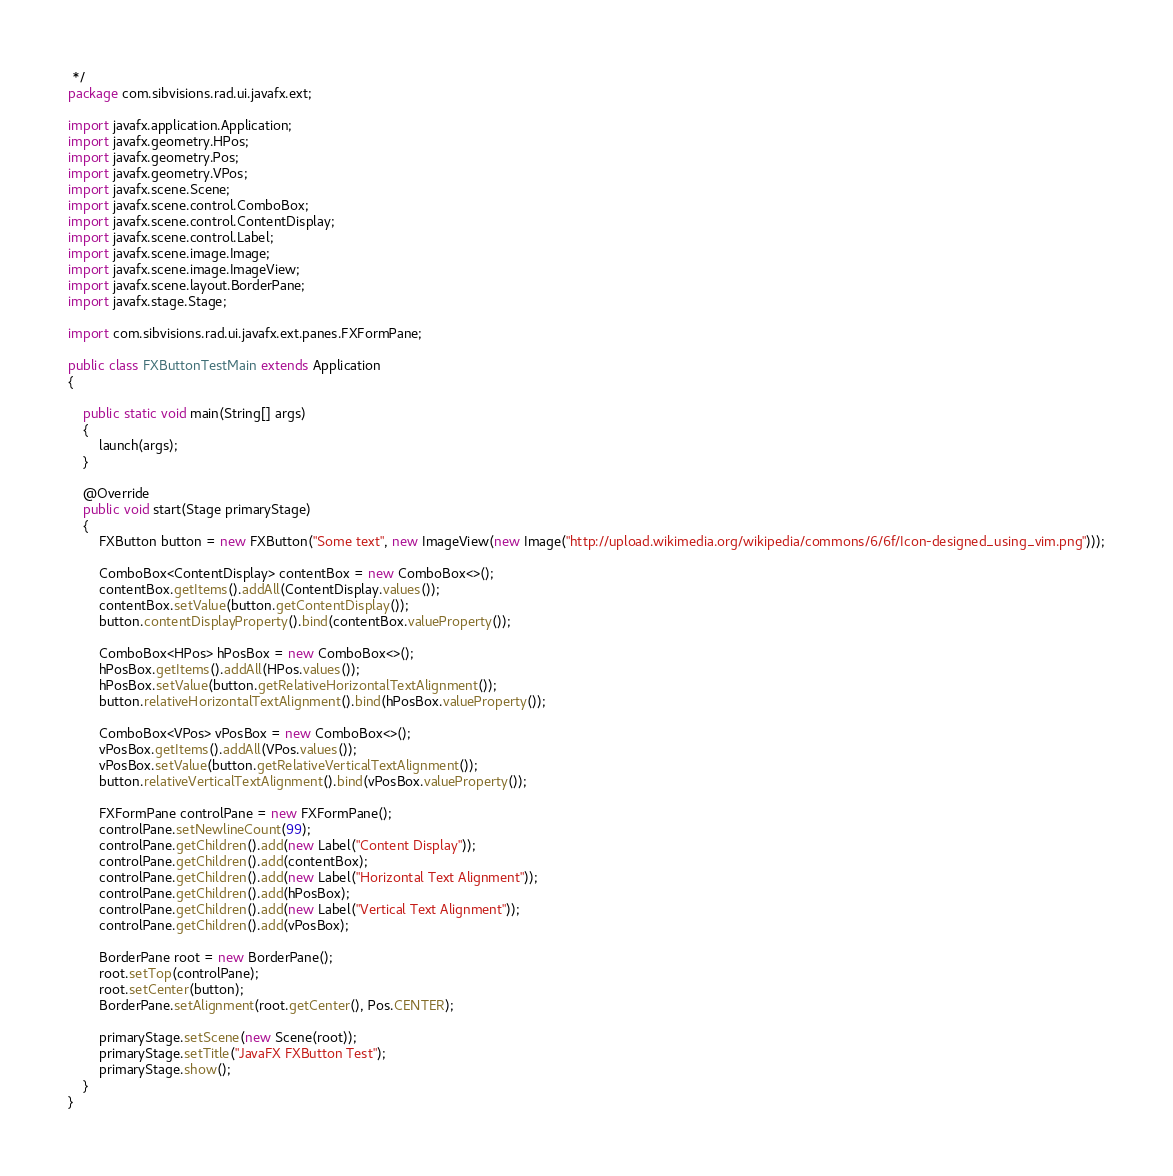<code> <loc_0><loc_0><loc_500><loc_500><_Java_> */
package com.sibvisions.rad.ui.javafx.ext;

import javafx.application.Application;
import javafx.geometry.HPos;
import javafx.geometry.Pos;
import javafx.geometry.VPos;
import javafx.scene.Scene;
import javafx.scene.control.ComboBox;
import javafx.scene.control.ContentDisplay;
import javafx.scene.control.Label;
import javafx.scene.image.Image;
import javafx.scene.image.ImageView;
import javafx.scene.layout.BorderPane;
import javafx.stage.Stage;

import com.sibvisions.rad.ui.javafx.ext.panes.FXFormPane;

public class FXButtonTestMain extends Application
{
	
	public static void main(String[] args)
	{
		launch(args);
	}
	
	@Override
	public void start(Stage primaryStage)
	{
		FXButton button = new FXButton("Some text", new ImageView(new Image("http://upload.wikimedia.org/wikipedia/commons/6/6f/Icon-designed_using_vim.png")));
		
		ComboBox<ContentDisplay> contentBox = new ComboBox<>();
		contentBox.getItems().addAll(ContentDisplay.values());
		contentBox.setValue(button.getContentDisplay());
		button.contentDisplayProperty().bind(contentBox.valueProperty());
		
		ComboBox<HPos> hPosBox = new ComboBox<>();
		hPosBox.getItems().addAll(HPos.values());
		hPosBox.setValue(button.getRelativeHorizontalTextAlignment());
		button.relativeHorizontalTextAlignment().bind(hPosBox.valueProperty());
		
		ComboBox<VPos> vPosBox = new ComboBox<>();
		vPosBox.getItems().addAll(VPos.values());
		vPosBox.setValue(button.getRelativeVerticalTextAlignment());
		button.relativeVerticalTextAlignment().bind(vPosBox.valueProperty());
		
		FXFormPane controlPane = new FXFormPane();
		controlPane.setNewlineCount(99);
		controlPane.getChildren().add(new Label("Content Display"));
		controlPane.getChildren().add(contentBox);
		controlPane.getChildren().add(new Label("Horizontal Text Alignment"));
		controlPane.getChildren().add(hPosBox);
		controlPane.getChildren().add(new Label("Vertical Text Alignment"));
		controlPane.getChildren().add(vPosBox);
		
		BorderPane root = new BorderPane();
		root.setTop(controlPane);
		root.setCenter(button);
		BorderPane.setAlignment(root.getCenter(), Pos.CENTER);
		
		primaryStage.setScene(new Scene(root));
		primaryStage.setTitle("JavaFX FXButton Test");
		primaryStage.show();
	}
}
</code> 